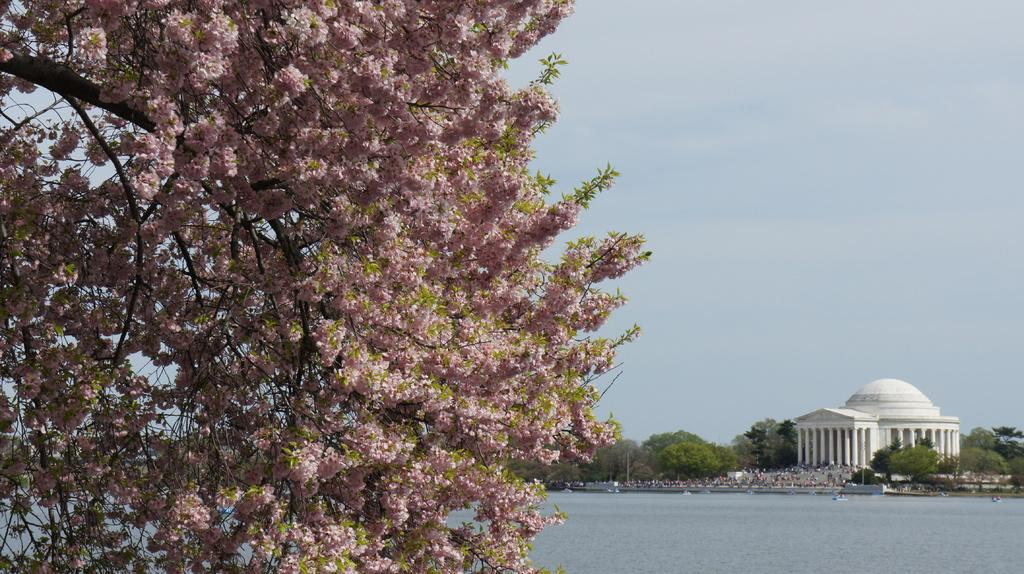What is located on the left side of the image? There is a tree on the left side of the image. What is behind the tree in the image? There is a lake behind the tree. What can be seen in the background of the image? There is a palace in the background of the image. What is present on either side of the palace? Trees are present on either side of the palace. What is visible above the palace in the image? The sky is visible above the palace. What type of cheese is floating in the lake in the image? There is no cheese present in the image; it features a tree, a lake, a palace, and trees on either side. How many jellyfish can be seen swimming in the lake in the image? There are no jellyfish present in the image; the lake is not shown to have any aquatic life. 